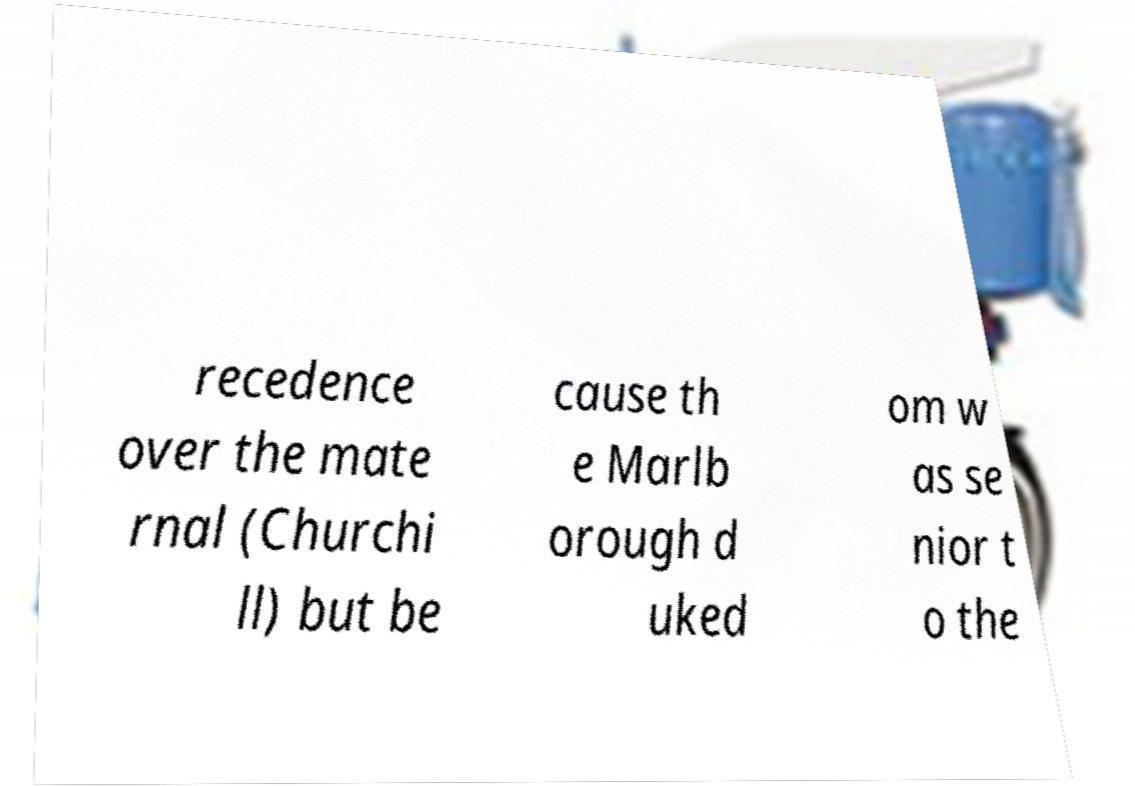Could you extract and type out the text from this image? recedence over the mate rnal (Churchi ll) but be cause th e Marlb orough d uked om w as se nior t o the 